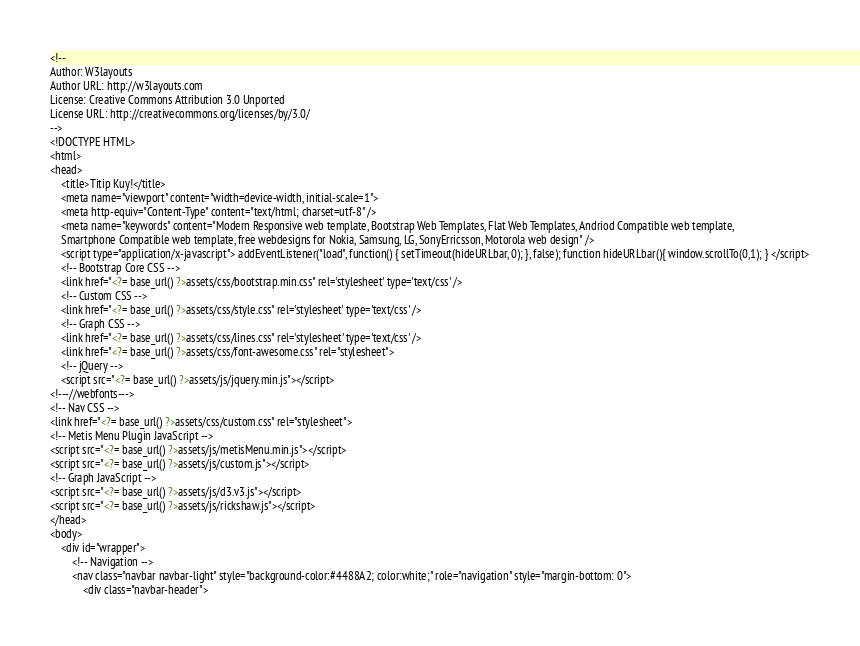Convert code to text. <code><loc_0><loc_0><loc_500><loc_500><_PHP_><!--
Author: W3layouts
Author URL: http://w3layouts.com
License: Creative Commons Attribution 3.0 Unported
License URL: http://creativecommons.org/licenses/by/3.0/
-->
<!DOCTYPE HTML>
<html>
<head>
	<title>Titip Kuy!</title>
	<meta name="viewport" content="width=device-width, initial-scale=1">
	<meta http-equiv="Content-Type" content="text/html; charset=utf-8" />
	<meta name="keywords" content="Modern Responsive web template, Bootstrap Web Templates, Flat Web Templates, Andriod Compatible web template, 
	Smartphone Compatible web template, free webdesigns for Nokia, Samsung, LG, SonyErricsson, Motorola web design" />
	<script type="application/x-javascript"> addEventListener("load", function() { setTimeout(hideURLbar, 0); }, false); function hideURLbar(){ window.scrollTo(0,1); } </script>
	<!-- Bootstrap Core CSS -->
	<link href="<?= base_url() ?>assets/css/bootstrap.min.css" rel='stylesheet' type='text/css' />
	<!-- Custom CSS -->
	<link href="<?= base_url() ?>assets/css/style.css" rel='stylesheet' type='text/css' />
	<!-- Graph CSS -->
	<link href="<?= base_url() ?>assets/css/lines.css" rel='stylesheet' type='text/css' />
	<link href="<?= base_url() ?>assets/css/font-awesome.css" rel="stylesheet"> 
	<!-- jQuery -->
	<script src="<?= base_url() ?>assets/js/jquery.min.js"></script>
<!---//webfonts--->  
<!-- Nav CSS -->
<link href="<?= base_url() ?>assets/css/custom.css" rel="stylesheet">
<!-- Metis Menu Plugin JavaScript -->
<script src="<?= base_url() ?>assets/js/metisMenu.min.js"></script>
<script src="<?= base_url() ?>assets/js/custom.js"></script>
<!-- Graph JavaScript -->
<script src="<?= base_url() ?>assets/js/d3.v3.js"></script>
<script src="<?= base_url() ?>assets/js/rickshaw.js"></script>
</head>
<body>
	<div id="wrapper">
		<!-- Navigation -->
		<nav class="navbar navbar-light" style="background-color:#4488A2; color:white;" role="navigation" style="margin-bottom: 0">
			<div class="navbar-header"></code> 